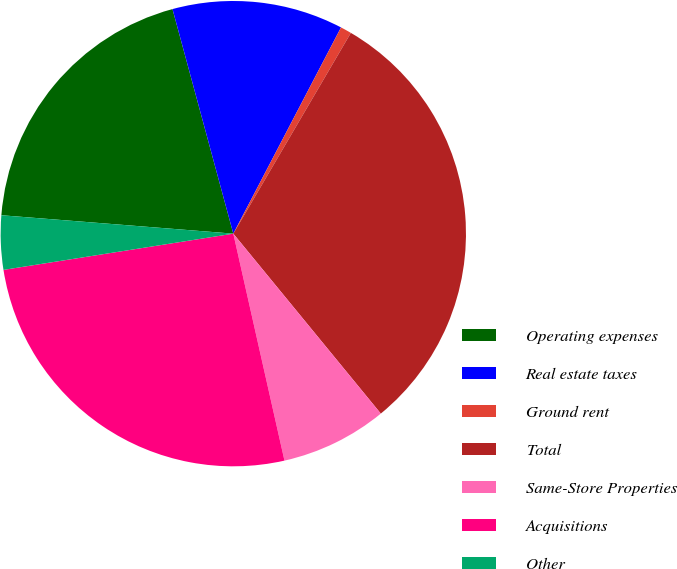Convert chart. <chart><loc_0><loc_0><loc_500><loc_500><pie_chart><fcel>Operating expenses<fcel>Real estate taxes<fcel>Ground rent<fcel>Total<fcel>Same-Store Properties<fcel>Acquisitions<fcel>Other<nl><fcel>19.53%<fcel>11.87%<fcel>0.77%<fcel>30.64%<fcel>7.4%<fcel>26.04%<fcel>3.75%<nl></chart> 